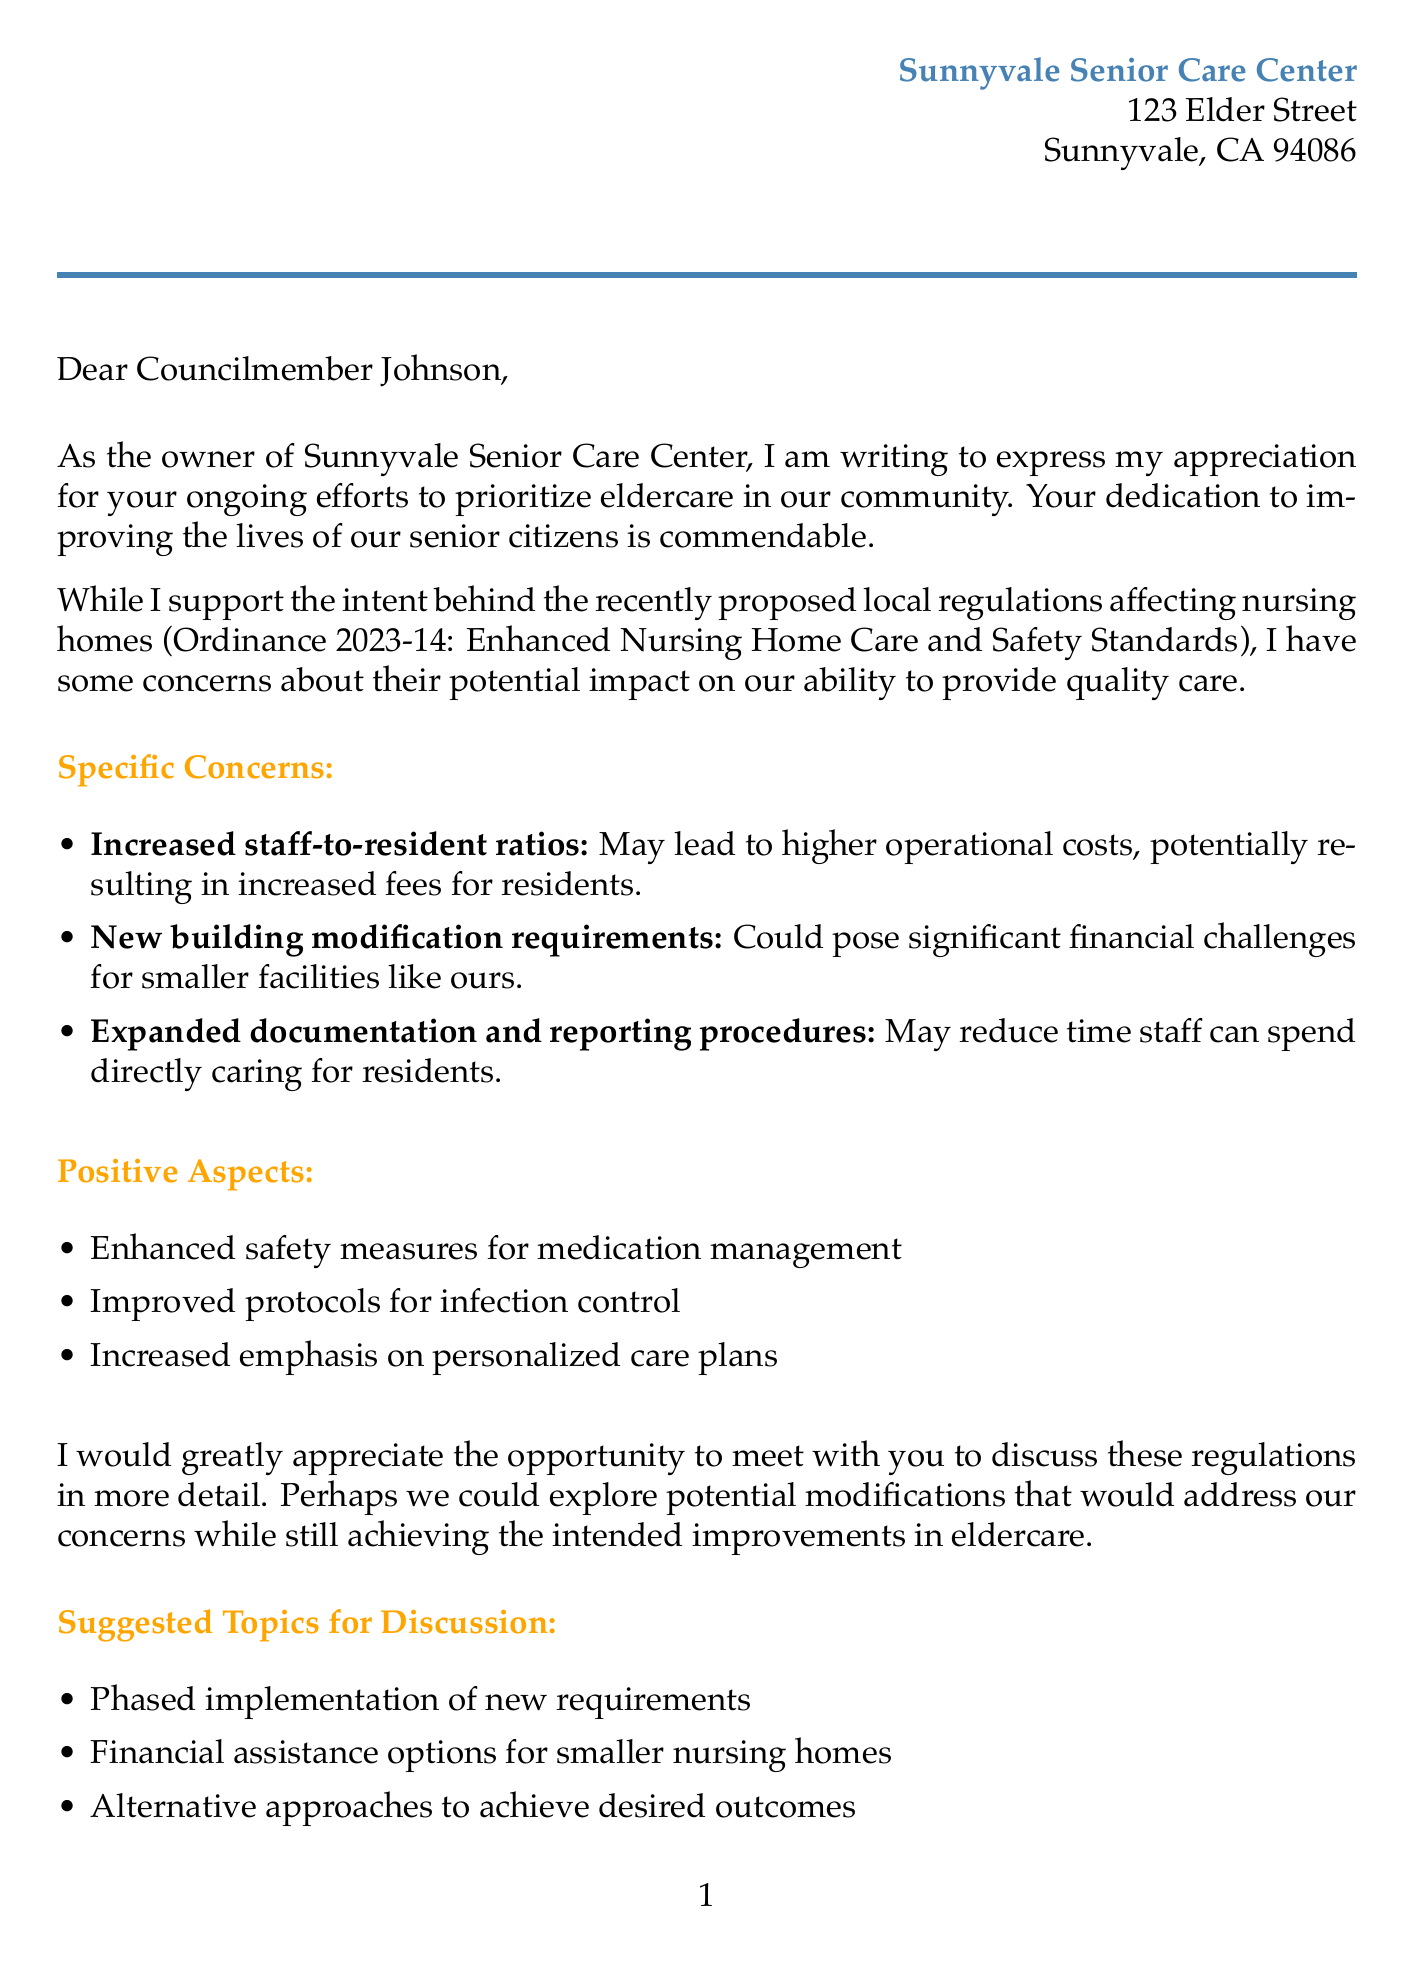What is the name of the nursing home? The letter mentions the nursing home as Sunnyvale Senior Care Center.
Answer: Sunnyvale Senior Care Center Who is the letter addressed to? The salutation of the letter indicates that it is addressed to Councilmember Johnson.
Answer: Councilmember Johnson What is the primary concern regarding staff-to-resident ratios? The letter states that increased staff-to-resident ratios may lead to higher operational costs.
Answer: Higher operational costs What ordinance is referenced in the letter? The letter mentions Ordinance 2023-14, which pertains to enhanced nursing home care and safety standards.
Answer: Ordinance 2023-14 What financial challenge is highlighted for smaller facilities? The letter notes that new building modification requirements could pose significant financial challenges for smaller facilities.
Answer: Significant financial challenges What is one suggested topic for discussion with the councilmember? The letter lists several suggested topics, one of which is financial assistance options for smaller nursing homes.
Answer: Financial assistance options for smaller nursing homes Who signed the letter? The closing of the letter includes the signature of Margaret Thompson, who is identified as the owner of the nursing home.
Answer: Margaret Thompson What positive aspect related to medication management is mentioned? The letter includes a positive aspect stating that there will be enhanced safety measures for medication management.
Answer: Enhanced safety measures for medication management 